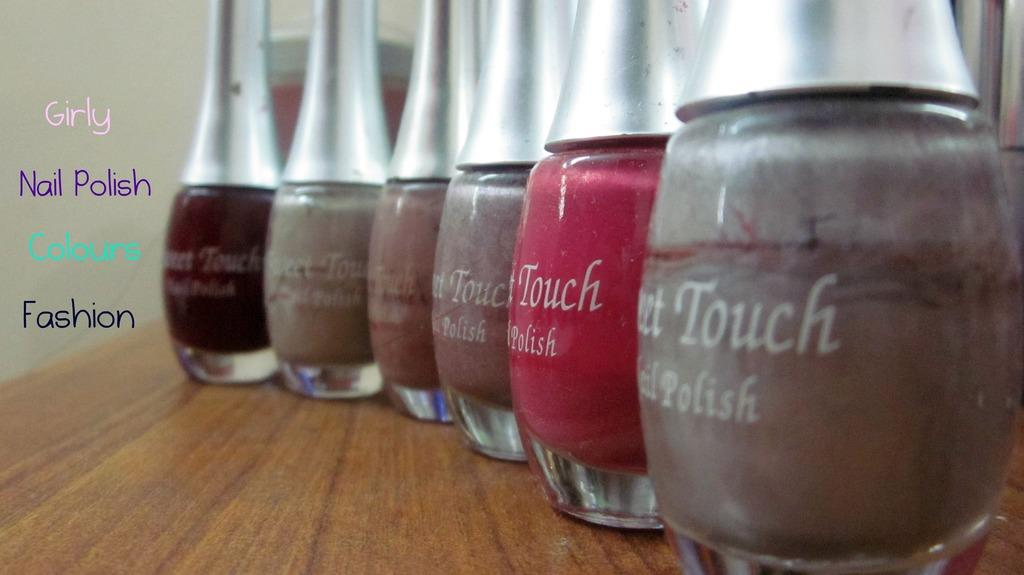What types of items are visible in the image? There are different colors of nail polishes in the image. What is the nail polish placed on? The nail polishes are placed on a brown table. What can be read or seen in the image? There are words visible in the image. What is visible in the background of the image? There is a wall in the background of the image. What type of flower is growing on the wall in the image? There is no flower visible on the wall in the image. 